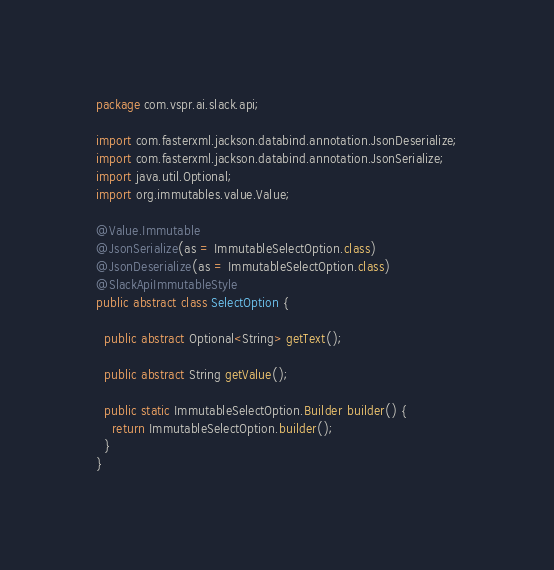Convert code to text. <code><loc_0><loc_0><loc_500><loc_500><_Java_>package com.vspr.ai.slack.api;

import com.fasterxml.jackson.databind.annotation.JsonDeserialize;
import com.fasterxml.jackson.databind.annotation.JsonSerialize;
import java.util.Optional;
import org.immutables.value.Value;

@Value.Immutable
@JsonSerialize(as = ImmutableSelectOption.class)
@JsonDeserialize(as = ImmutableSelectOption.class)
@SlackApiImmutableStyle
public abstract class SelectOption {

  public abstract Optional<String> getText();

  public abstract String getValue();

  public static ImmutableSelectOption.Builder builder() {
    return ImmutableSelectOption.builder();
  }
}
</code> 